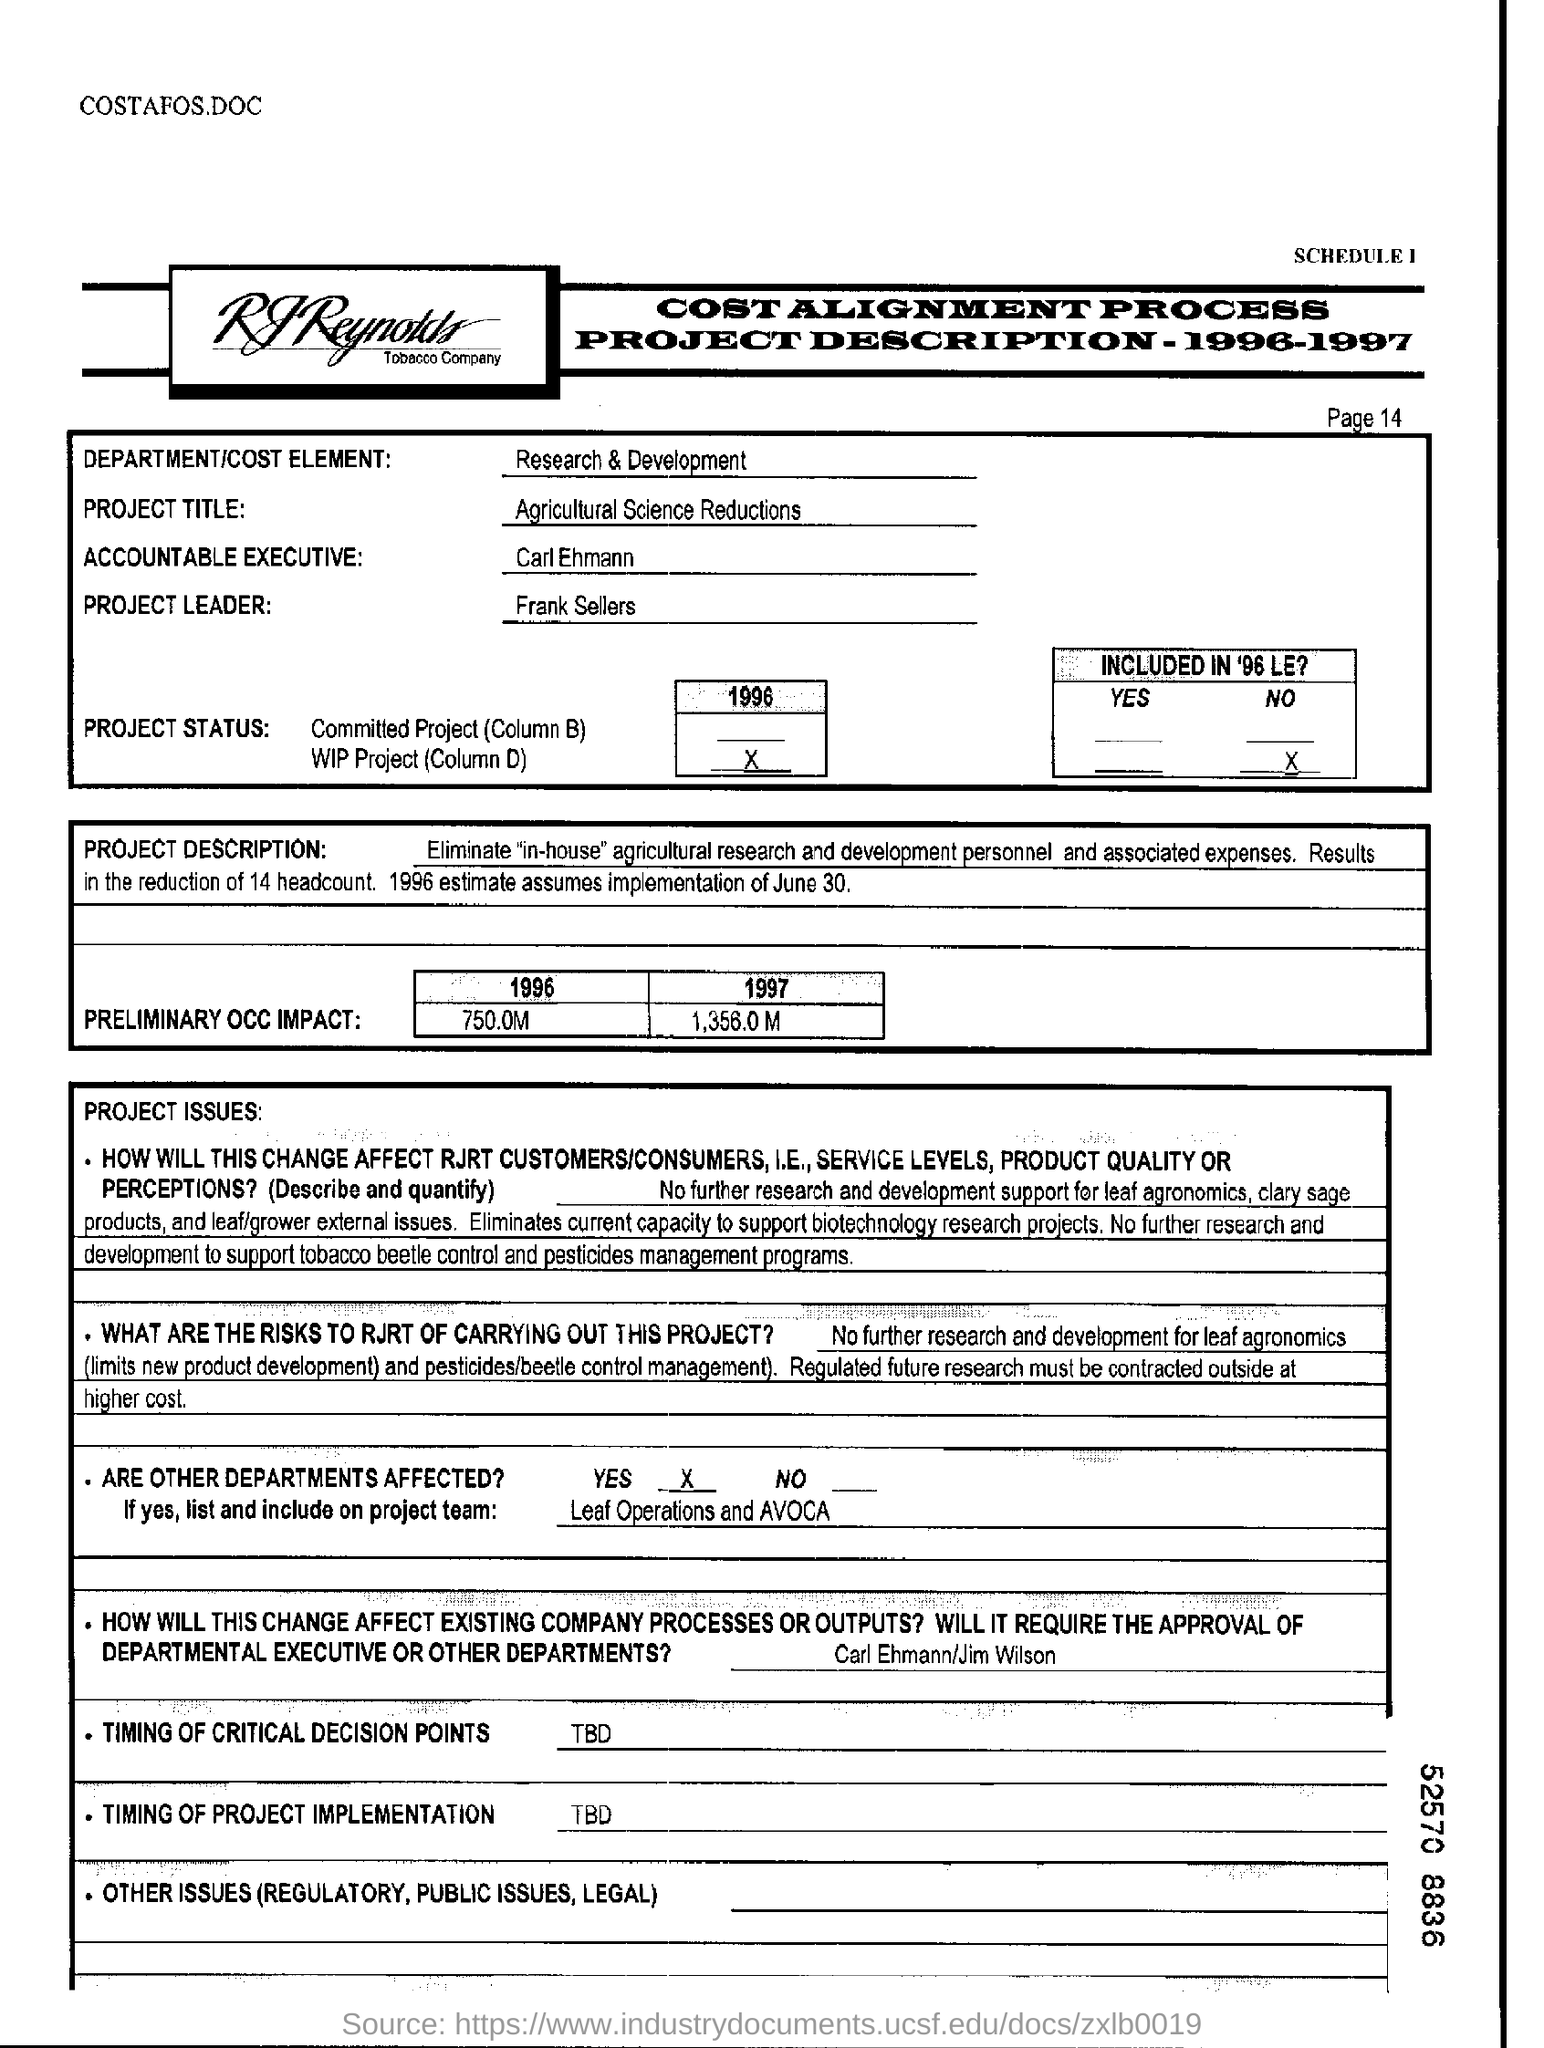Who is the project leader ?
Your answer should be very brief. Frank sellers. What is the project title ?
Keep it short and to the point. AGRICULTURAL SCIENCE REDUCTIONS. Are there any other departments affected ?
Offer a terse response. Yes. How much is the preliminary occ impact in year "1996"?
Ensure brevity in your answer.  750.0m. What is the page number ?
Your answer should be compact. 14. What is the amount of preliminary occ impact in year "1997"?
Provide a succinct answer. 1,356.0 M. What is the department/ cost element ?
Offer a very short reply. Research & Development. What date is assumed for implementation by estimates of 1996?
Make the answer very short. June 30. What is the schedule number at top of the page ?
Make the answer very short. 1. 